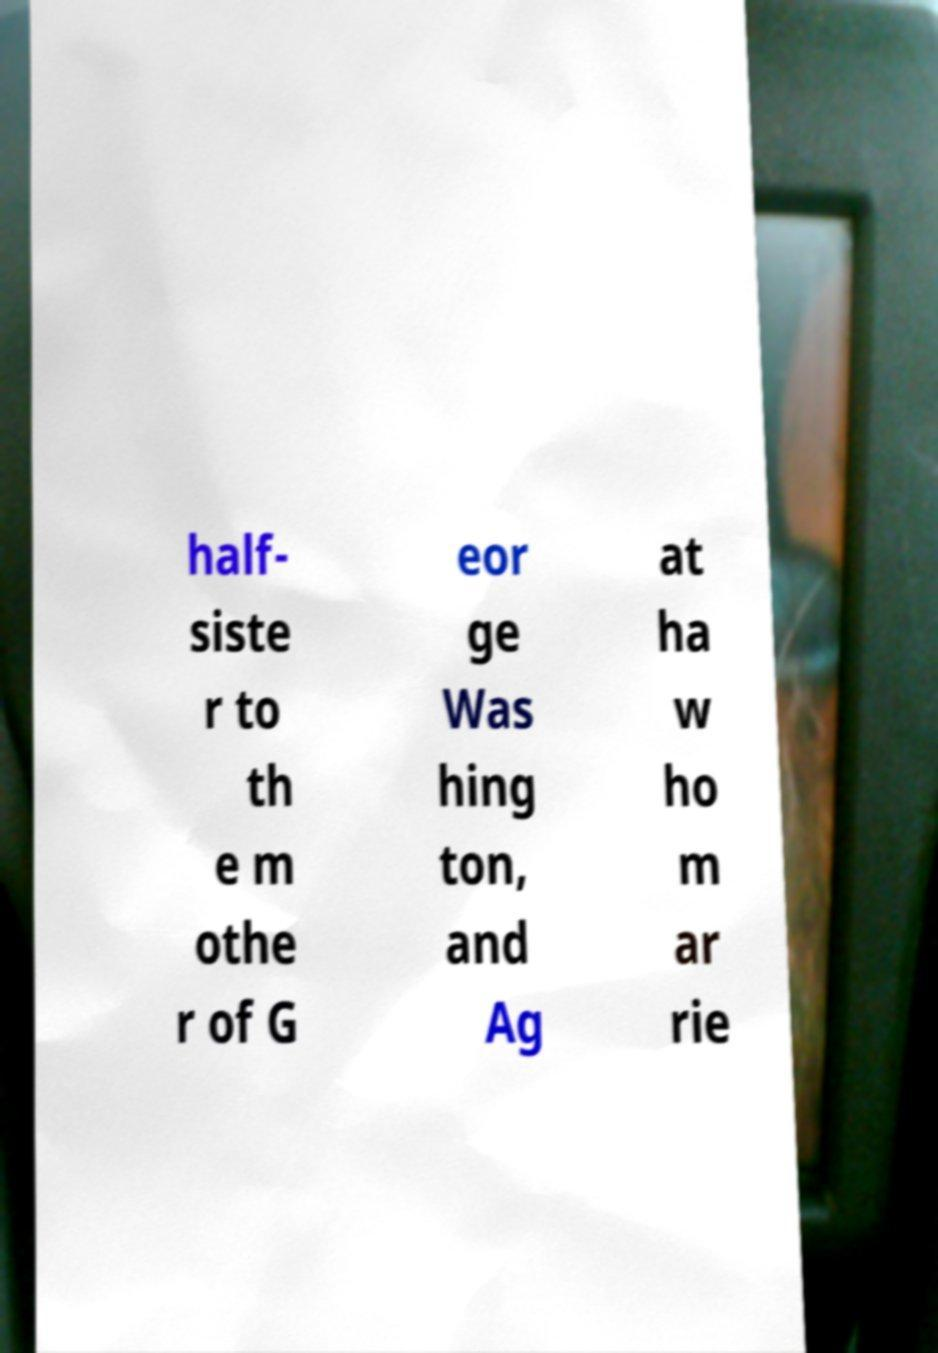Can you accurately transcribe the text from the provided image for me? half- siste r to th e m othe r of G eor ge Was hing ton, and Ag at ha w ho m ar rie 